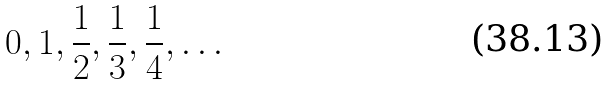<formula> <loc_0><loc_0><loc_500><loc_500>0 , 1 , \frac { 1 } { 2 } , \frac { 1 } { 3 } , \frac { 1 } { 4 } , \dots</formula> 